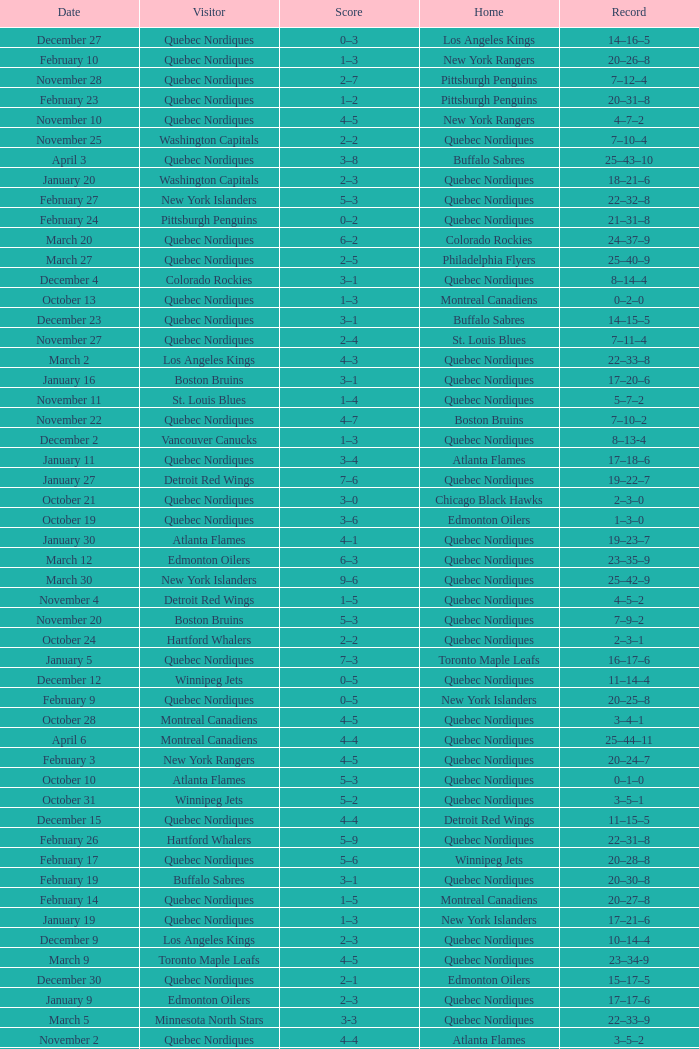Which Record has a Home of edmonton oilers, and a Score of 3–6? 1–3–0. 